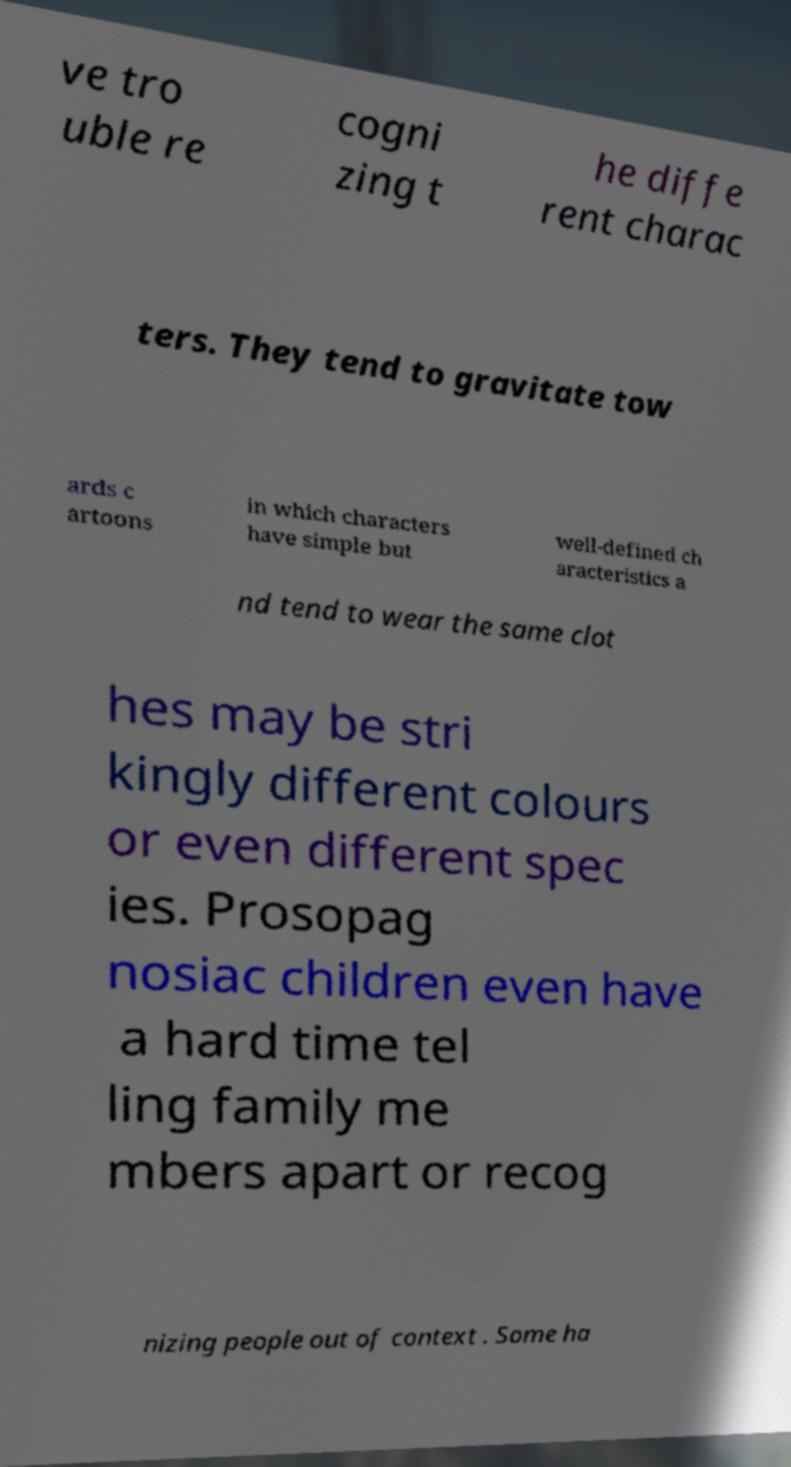Could you extract and type out the text from this image? ve tro uble re cogni zing t he diffe rent charac ters. They tend to gravitate tow ards c artoons in which characters have simple but well-defined ch aracteristics a nd tend to wear the same clot hes may be stri kingly different colours or even different spec ies. Prosopag nosiac children even have a hard time tel ling family me mbers apart or recog nizing people out of context . Some ha 